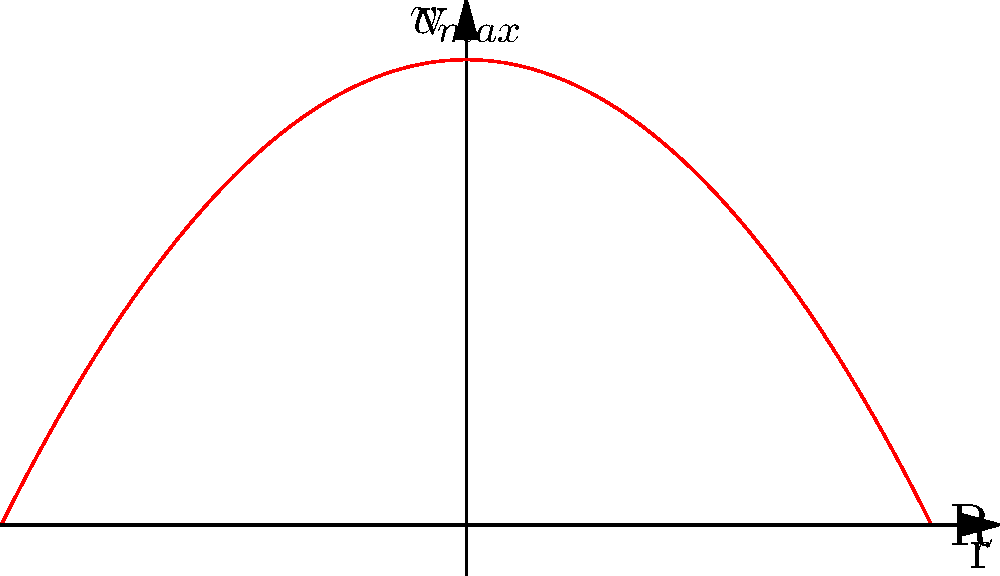As an artist interested in fluid dynamics for a new installation, you're studying the velocity profile of fluid flow in a pipe. The graph shows the velocity profile for fully developed laminar flow. If the maximum velocity at the center of the pipe is 2 m/s and the pipe radius is 2 cm, what is the average velocity of the fluid in the pipe? To find the average velocity, we need to follow these steps:

1. Recognize that the velocity profile for fully developed laminar flow in a pipe is parabolic.

2. The equation for the velocity profile is:

   $$ v(r) = v_{max}(1 - (\frac{r}{R})^2) $$

   where $v_{max}$ is the maximum velocity at the center, $r$ is the radial distance from the center, and $R$ is the pipe radius.

3. The average velocity $v_{avg}$ is related to the maximum velocity $v_{max}$ by:

   $$ v_{avg} = \frac{1}{2}v_{max} $$

4. Given:
   $v_{max} = 2$ m/s
   $R = 2$ cm (radius doesn't affect the ratio)

5. Calculate:
   $$ v_{avg} = \frac{1}{2} \times 2 \text{ m/s} = 1 \text{ m/s} $$

Therefore, the average velocity of the fluid in the pipe is 1 m/s.
Answer: 1 m/s 